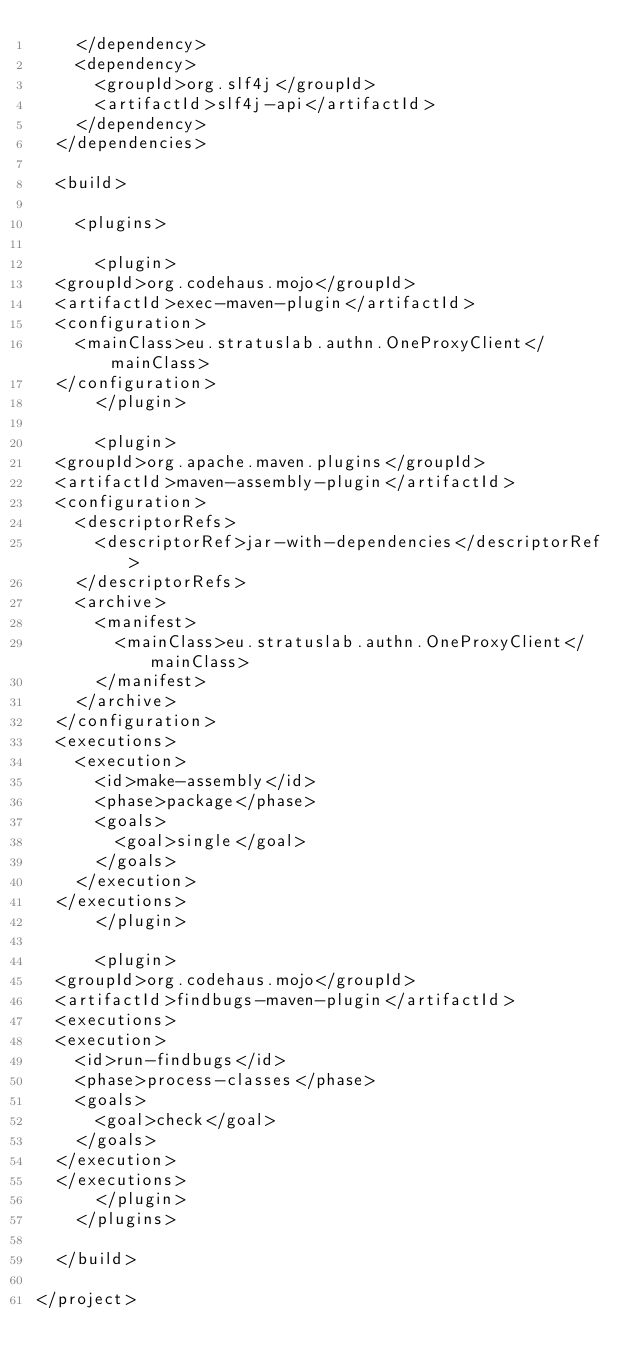<code> <loc_0><loc_0><loc_500><loc_500><_XML_>    </dependency>
    <dependency>
      <groupId>org.slf4j</groupId>
      <artifactId>slf4j-api</artifactId>
    </dependency>
  </dependencies>

  <build>

    <plugins>

      <plugin>
	<groupId>org.codehaus.mojo</groupId>
	<artifactId>exec-maven-plugin</artifactId>
	<configuration>
	  <mainClass>eu.stratuslab.authn.OneProxyClient</mainClass>
	</configuration>
      </plugin>

      <plugin>
	<groupId>org.apache.maven.plugins</groupId>
	<artifactId>maven-assembly-plugin</artifactId>
	<configuration>
	  <descriptorRefs>
	    <descriptorRef>jar-with-dependencies</descriptorRef>
	  </descriptorRefs>
	  <archive>
	    <manifest>
	      <mainClass>eu.stratuslab.authn.OneProxyClient</mainClass>
	    </manifest>
	  </archive>
	</configuration>
	<executions>
	  <execution>
	    <id>make-assembly</id>
	    <phase>package</phase>
	    <goals>
	      <goal>single</goal>
	    </goals>
	  </execution>
	</executions>
      </plugin>

      <plugin>
	<groupId>org.codehaus.mojo</groupId>
	<artifactId>findbugs-maven-plugin</artifactId>
	<executions>
	<execution>
	  <id>run-findbugs</id>
	  <phase>process-classes</phase>
	  <goals>
	    <goal>check</goal>
	  </goals>
	</execution>
	</executions>
      </plugin>
    </plugins>

  </build>

</project>
</code> 